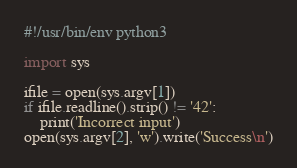Convert code to text. <code><loc_0><loc_0><loc_500><loc_500><_Python_>#!/usr/bin/env python3

import sys

ifile = open(sys.argv[1])
if ifile.readline().strip() != '42':
    print('Incorrect input')
open(sys.argv[2], 'w').write('Success\n')
</code> 